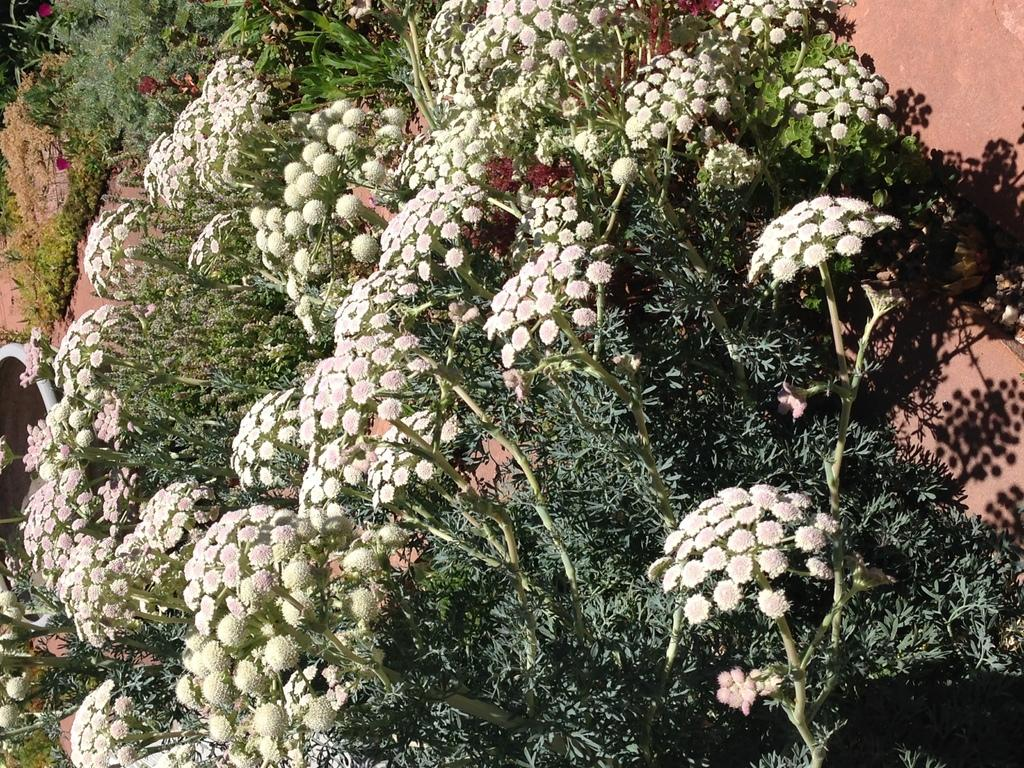What type of vegetation can be seen in the image? There are flowers and plants in the image. What is the background of the image? There is a wall in the image. What type of pipe is visible in the image? There is no pipe present in the image. What is the visibility level in the image due to the fog? There is no fog present in the image, so it cannot affect visibility. 